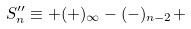Convert formula to latex. <formula><loc_0><loc_0><loc_500><loc_500>S ^ { \prime \prime } _ { n } \equiv + ( + ) _ { \infty } - ( - ) _ { n - 2 } +</formula> 